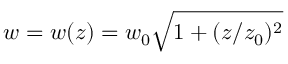Convert formula to latex. <formula><loc_0><loc_0><loc_500><loc_500>w = w ( z ) = w _ { 0 } \sqrt { 1 + ( z / z _ { 0 } ) ^ { 2 } }</formula> 